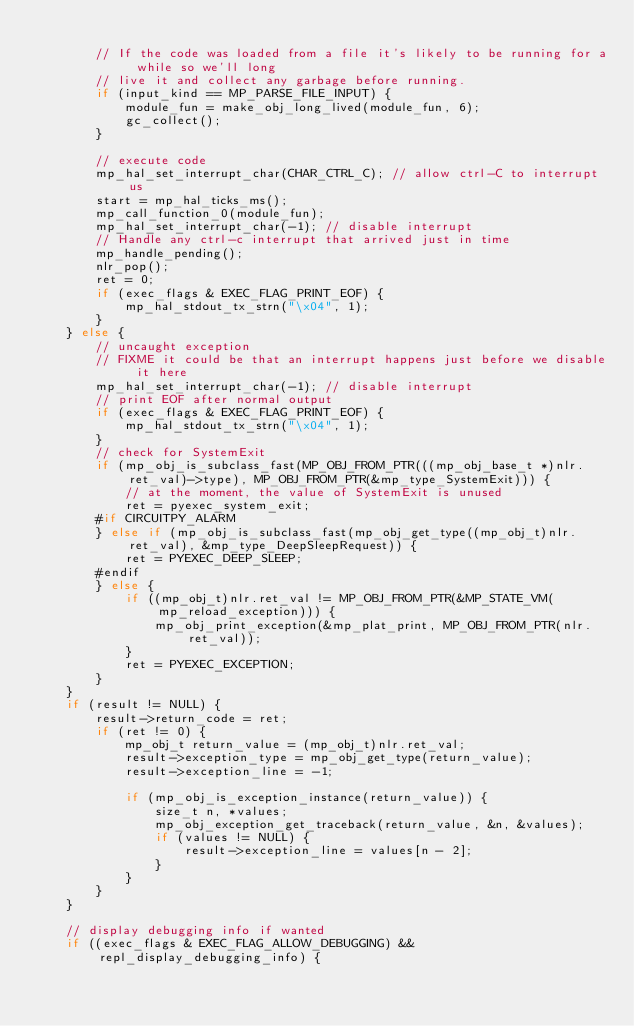<code> <loc_0><loc_0><loc_500><loc_500><_C_>
        // If the code was loaded from a file it's likely to be running for a while so we'll long
        // live it and collect any garbage before running.
        if (input_kind == MP_PARSE_FILE_INPUT) {
            module_fun = make_obj_long_lived(module_fun, 6);
            gc_collect();
        }

        // execute code
        mp_hal_set_interrupt_char(CHAR_CTRL_C); // allow ctrl-C to interrupt us
        start = mp_hal_ticks_ms();
        mp_call_function_0(module_fun);
        mp_hal_set_interrupt_char(-1); // disable interrupt
        // Handle any ctrl-c interrupt that arrived just in time
        mp_handle_pending();
        nlr_pop();
        ret = 0;
        if (exec_flags & EXEC_FLAG_PRINT_EOF) {
            mp_hal_stdout_tx_strn("\x04", 1);
        }
    } else {
        // uncaught exception
        // FIXME it could be that an interrupt happens just before we disable it here
        mp_hal_set_interrupt_char(-1); // disable interrupt
        // print EOF after normal output
        if (exec_flags & EXEC_FLAG_PRINT_EOF) {
            mp_hal_stdout_tx_strn("\x04", 1);
        }
        // check for SystemExit
        if (mp_obj_is_subclass_fast(MP_OBJ_FROM_PTR(((mp_obj_base_t *)nlr.ret_val)->type), MP_OBJ_FROM_PTR(&mp_type_SystemExit))) {
            // at the moment, the value of SystemExit is unused
            ret = pyexec_system_exit;
        #if CIRCUITPY_ALARM
        } else if (mp_obj_is_subclass_fast(mp_obj_get_type((mp_obj_t)nlr.ret_val), &mp_type_DeepSleepRequest)) {
            ret = PYEXEC_DEEP_SLEEP;
        #endif
        } else {
            if ((mp_obj_t)nlr.ret_val != MP_OBJ_FROM_PTR(&MP_STATE_VM(mp_reload_exception))) {
                mp_obj_print_exception(&mp_plat_print, MP_OBJ_FROM_PTR(nlr.ret_val));
            }
            ret = PYEXEC_EXCEPTION;
        }
    }
    if (result != NULL) {
        result->return_code = ret;
        if (ret != 0) {
            mp_obj_t return_value = (mp_obj_t)nlr.ret_val;
            result->exception_type = mp_obj_get_type(return_value);
            result->exception_line = -1;

            if (mp_obj_is_exception_instance(return_value)) {
                size_t n, *values;
                mp_obj_exception_get_traceback(return_value, &n, &values);
                if (values != NULL) {
                    result->exception_line = values[n - 2];
                }
            }
        }
    }

    // display debugging info if wanted
    if ((exec_flags & EXEC_FLAG_ALLOW_DEBUGGING) && repl_display_debugging_info) {</code> 